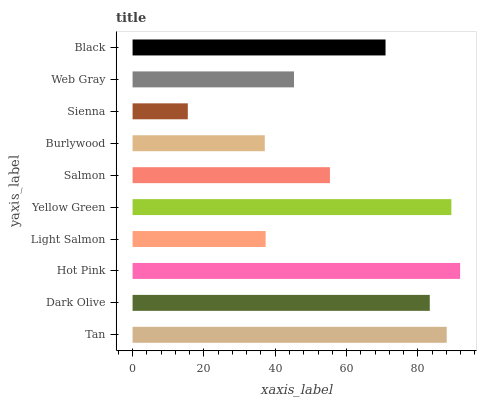Is Sienna the minimum?
Answer yes or no. Yes. Is Hot Pink the maximum?
Answer yes or no. Yes. Is Dark Olive the minimum?
Answer yes or no. No. Is Dark Olive the maximum?
Answer yes or no. No. Is Tan greater than Dark Olive?
Answer yes or no. Yes. Is Dark Olive less than Tan?
Answer yes or no. Yes. Is Dark Olive greater than Tan?
Answer yes or no. No. Is Tan less than Dark Olive?
Answer yes or no. No. Is Black the high median?
Answer yes or no. Yes. Is Salmon the low median?
Answer yes or no. Yes. Is Sienna the high median?
Answer yes or no. No. Is Light Salmon the low median?
Answer yes or no. No. 